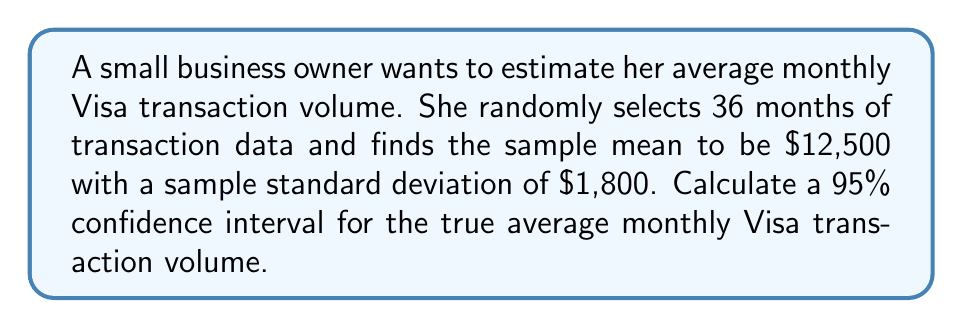Show me your answer to this math problem. To calculate the confidence interval, we'll follow these steps:

1) We're given:
   - Sample size: $n = 36$
   - Sample mean: $\bar{x} = \$12,500$
   - Sample standard deviation: $s = \$1,800$
   - Confidence level: 95%

2) For a 95% confidence interval, we use a $z$-score of 1.96 (assuming normal distribution due to large sample size).

3) The formula for the confidence interval is:

   $$\bar{x} \pm z \cdot \frac{s}{\sqrt{n}}$$

4) Let's calculate the margin of error:

   $$\text{Margin of Error} = 1.96 \cdot \frac{1800}{\sqrt{36}} = 1.96 \cdot \frac{1800}{6} = 1.96 \cdot 300 = 588$$

5) Now, we can calculate the confidence interval:

   Lower bound: $12,500 - 588 = 11,912$
   Upper bound: $12,500 + 588 = 13,088$

6) Therefore, the 95% confidence interval is ($11,912, $13,088).

This means we can be 95% confident that the true average monthly Visa transaction volume falls between $11,912 and $13,088.
Answer: ($11,912, $13,088) 